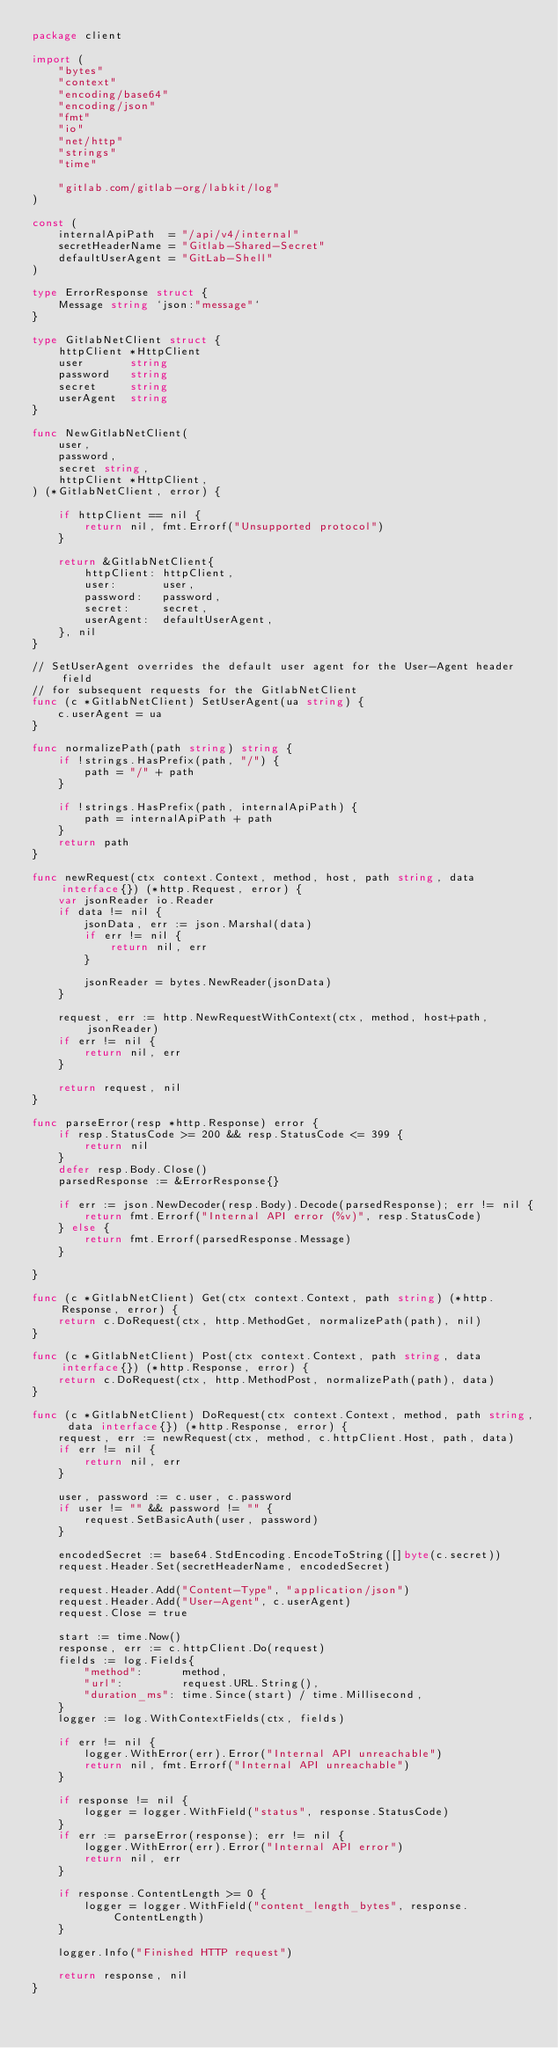<code> <loc_0><loc_0><loc_500><loc_500><_Go_>package client

import (
	"bytes"
	"context"
	"encoding/base64"
	"encoding/json"
	"fmt"
	"io"
	"net/http"
	"strings"
	"time"

	"gitlab.com/gitlab-org/labkit/log"
)

const (
	internalApiPath  = "/api/v4/internal"
	secretHeaderName = "Gitlab-Shared-Secret"
	defaultUserAgent = "GitLab-Shell"
)

type ErrorResponse struct {
	Message string `json:"message"`
}

type GitlabNetClient struct {
	httpClient *HttpClient
	user       string
	password   string
	secret     string
	userAgent  string
}

func NewGitlabNetClient(
	user,
	password,
	secret string,
	httpClient *HttpClient,
) (*GitlabNetClient, error) {

	if httpClient == nil {
		return nil, fmt.Errorf("Unsupported protocol")
	}

	return &GitlabNetClient{
		httpClient: httpClient,
		user:       user,
		password:   password,
		secret:     secret,
		userAgent:  defaultUserAgent,
	}, nil
}

// SetUserAgent overrides the default user agent for the User-Agent header field
// for subsequent requests for the GitlabNetClient
func (c *GitlabNetClient) SetUserAgent(ua string) {
	c.userAgent = ua
}

func normalizePath(path string) string {
	if !strings.HasPrefix(path, "/") {
		path = "/" + path
	}

	if !strings.HasPrefix(path, internalApiPath) {
		path = internalApiPath + path
	}
	return path
}

func newRequest(ctx context.Context, method, host, path string, data interface{}) (*http.Request, error) {
	var jsonReader io.Reader
	if data != nil {
		jsonData, err := json.Marshal(data)
		if err != nil {
			return nil, err
		}

		jsonReader = bytes.NewReader(jsonData)
	}

	request, err := http.NewRequestWithContext(ctx, method, host+path, jsonReader)
	if err != nil {
		return nil, err
	}

	return request, nil
}

func parseError(resp *http.Response) error {
	if resp.StatusCode >= 200 && resp.StatusCode <= 399 {
		return nil
	}
	defer resp.Body.Close()
	parsedResponse := &ErrorResponse{}

	if err := json.NewDecoder(resp.Body).Decode(parsedResponse); err != nil {
		return fmt.Errorf("Internal API error (%v)", resp.StatusCode)
	} else {
		return fmt.Errorf(parsedResponse.Message)
	}

}

func (c *GitlabNetClient) Get(ctx context.Context, path string) (*http.Response, error) {
	return c.DoRequest(ctx, http.MethodGet, normalizePath(path), nil)
}

func (c *GitlabNetClient) Post(ctx context.Context, path string, data interface{}) (*http.Response, error) {
	return c.DoRequest(ctx, http.MethodPost, normalizePath(path), data)
}

func (c *GitlabNetClient) DoRequest(ctx context.Context, method, path string, data interface{}) (*http.Response, error) {
	request, err := newRequest(ctx, method, c.httpClient.Host, path, data)
	if err != nil {
		return nil, err
	}

	user, password := c.user, c.password
	if user != "" && password != "" {
		request.SetBasicAuth(user, password)
	}

	encodedSecret := base64.StdEncoding.EncodeToString([]byte(c.secret))
	request.Header.Set(secretHeaderName, encodedSecret)

	request.Header.Add("Content-Type", "application/json")
	request.Header.Add("User-Agent", c.userAgent)
	request.Close = true

	start := time.Now()
	response, err := c.httpClient.Do(request)
	fields := log.Fields{
		"method":      method,
		"url":         request.URL.String(),
		"duration_ms": time.Since(start) / time.Millisecond,
	}
	logger := log.WithContextFields(ctx, fields)

	if err != nil {
		logger.WithError(err).Error("Internal API unreachable")
		return nil, fmt.Errorf("Internal API unreachable")
	}

	if response != nil {
		logger = logger.WithField("status", response.StatusCode)
	}
	if err := parseError(response); err != nil {
		logger.WithError(err).Error("Internal API error")
		return nil, err
	}

	if response.ContentLength >= 0 {
		logger = logger.WithField("content_length_bytes", response.ContentLength)
	}

	logger.Info("Finished HTTP request")

	return response, nil
}
</code> 